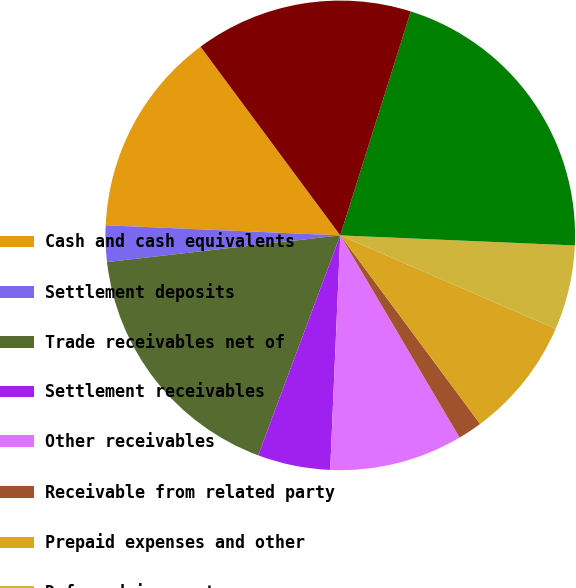Convert chart to OTSL. <chart><loc_0><loc_0><loc_500><loc_500><pie_chart><fcel>Cash and cash equivalents<fcel>Settlement deposits<fcel>Trade receivables net of<fcel>Settlement receivables<fcel>Other receivables<fcel>Receivable from related party<fcel>Prepaid expenses and other<fcel>Deferred income taxes<fcel>Total current assets<fcel>Property and equipment net of<nl><fcel>14.17%<fcel>2.5%<fcel>17.5%<fcel>5.0%<fcel>9.17%<fcel>1.67%<fcel>8.33%<fcel>5.83%<fcel>20.83%<fcel>15.0%<nl></chart> 